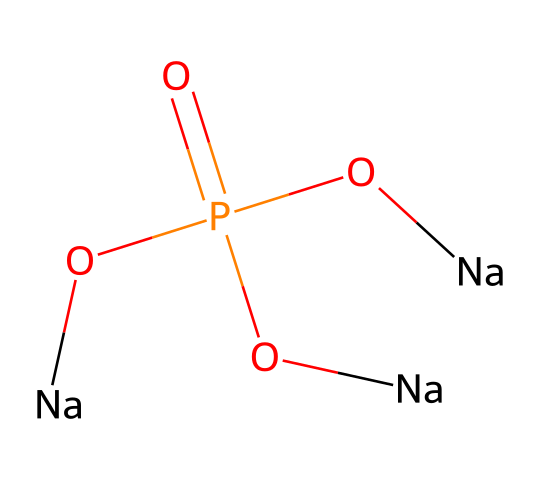What is the central atom in this compound? The compound's structure shows a phosphorus atom at the center, which is attached to four oxygen atoms around it. This indicates that phosphorus is the central atom.
Answer: phosphorus How many sodium atoms are present in the structure? By examining the structure, we see that there are three sodium atoms bonded to oxygen that are also connected to phosphorus. Thus, the total number of sodium atoms is three.
Answer: three What type of bonding is predominant in this compound? The predominant bonding in this compound involves both covalent bonds (between phosphorus and oxygen) and ionic bonds (between sodium and oxygen), but the key feature here is covalent bonding due to the shared electron pairs.
Answer: covalent What is the total number of oxygen atoms in the chemical structure? Counting the number of oxygen atoms in the structure reveals four oxygen atoms in total: three are bonded to sodium and one is bonded directly to phosphorus.
Answer: four Which characteristic of this compound classifies it as hypervalent? Hypervalent compounds are identified by having a central atom that is bonded to more atoms than its valence electrons would typically allow. In this case, phosphorus is bonded to four oxygen atoms, exceeding its typical valence of three.
Answer: bonded to four What role does this compound play in laundry detergents? The compound acts as a water softener, which helps in reducing water hardness by binding to calcium and magnesium ions, thus improving the effectiveness of the detergent.
Answer: water softener Is this compound an acid or a salt? Given the presence of sodium ions and anionic structure, this compound behaves as a salt, derived from the neutralization of an acid (phosphoric acid) by sodium hydroxide.
Answer: salt 